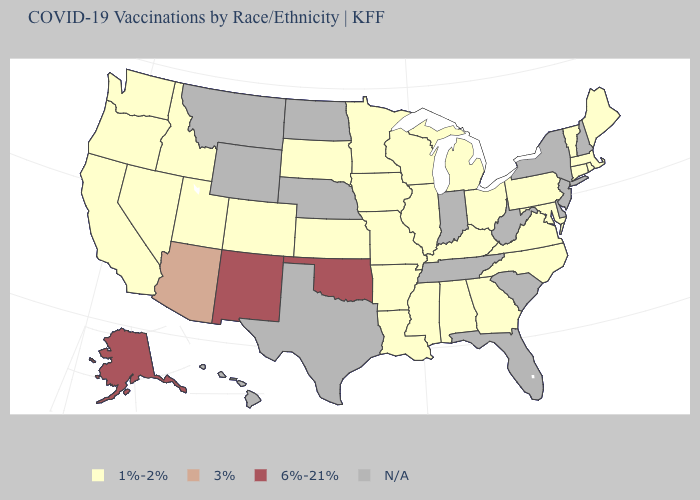What is the highest value in states that border Rhode Island?
Keep it brief. 1%-2%. What is the lowest value in the MidWest?
Write a very short answer. 1%-2%. Is the legend a continuous bar?
Give a very brief answer. No. Name the states that have a value in the range N/A?
Quick response, please. Delaware, Florida, Hawaii, Indiana, Montana, Nebraska, New Hampshire, New Jersey, New York, North Dakota, South Carolina, Tennessee, Texas, West Virginia, Wyoming. What is the value of Massachusetts?
Be succinct. 1%-2%. Is the legend a continuous bar?
Short answer required. No. Among the states that border California , which have the lowest value?
Be succinct. Nevada, Oregon. Name the states that have a value in the range 3%?
Give a very brief answer. Arizona. What is the lowest value in the USA?
Write a very short answer. 1%-2%. What is the value of Texas?
Keep it brief. N/A. What is the value of Indiana?
Short answer required. N/A. How many symbols are there in the legend?
Quick response, please. 4. Among the states that border Colorado , does New Mexico have the lowest value?
Be succinct. No. Name the states that have a value in the range 3%?
Be succinct. Arizona. 